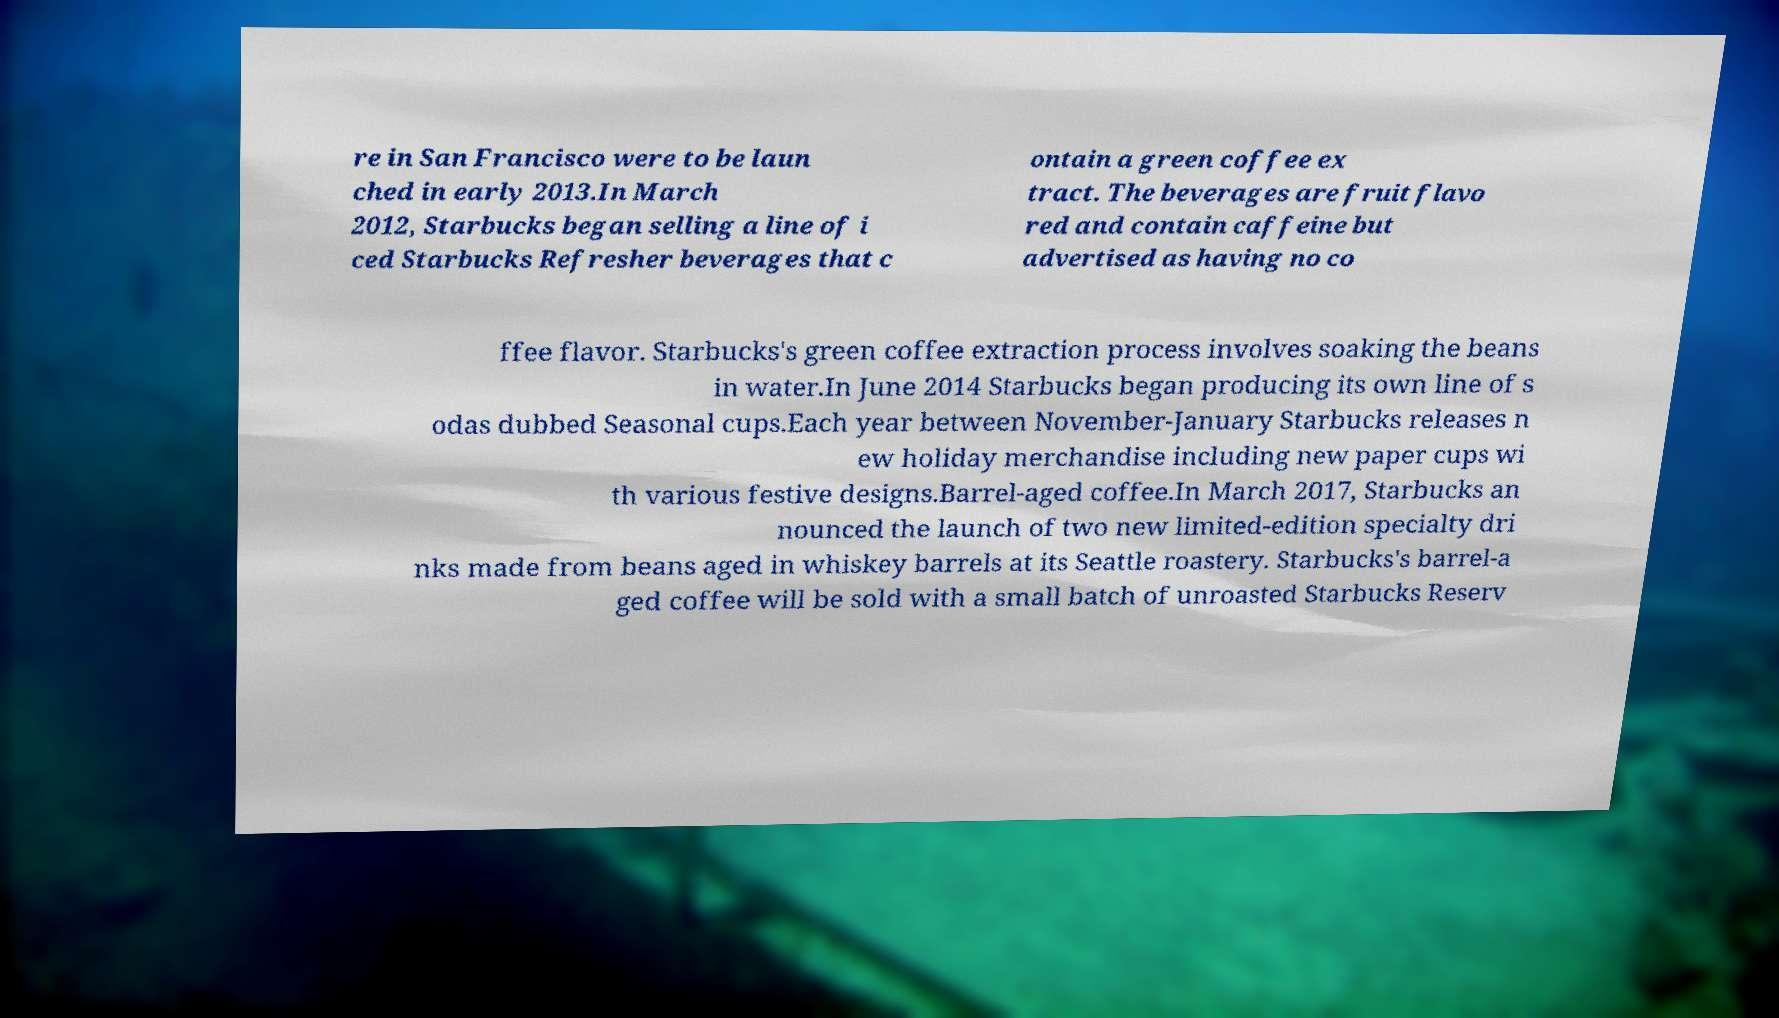Please identify and transcribe the text found in this image. re in San Francisco were to be laun ched in early 2013.In March 2012, Starbucks began selling a line of i ced Starbucks Refresher beverages that c ontain a green coffee ex tract. The beverages are fruit flavo red and contain caffeine but advertised as having no co ffee flavor. Starbucks's green coffee extraction process involves soaking the beans in water.In June 2014 Starbucks began producing its own line of s odas dubbed Seasonal cups.Each year between November-January Starbucks releases n ew holiday merchandise including new paper cups wi th various festive designs.Barrel-aged coffee.In March 2017, Starbucks an nounced the launch of two new limited-edition specialty dri nks made from beans aged in whiskey barrels at its Seattle roastery. Starbucks's barrel-a ged coffee will be sold with a small batch of unroasted Starbucks Reserv 